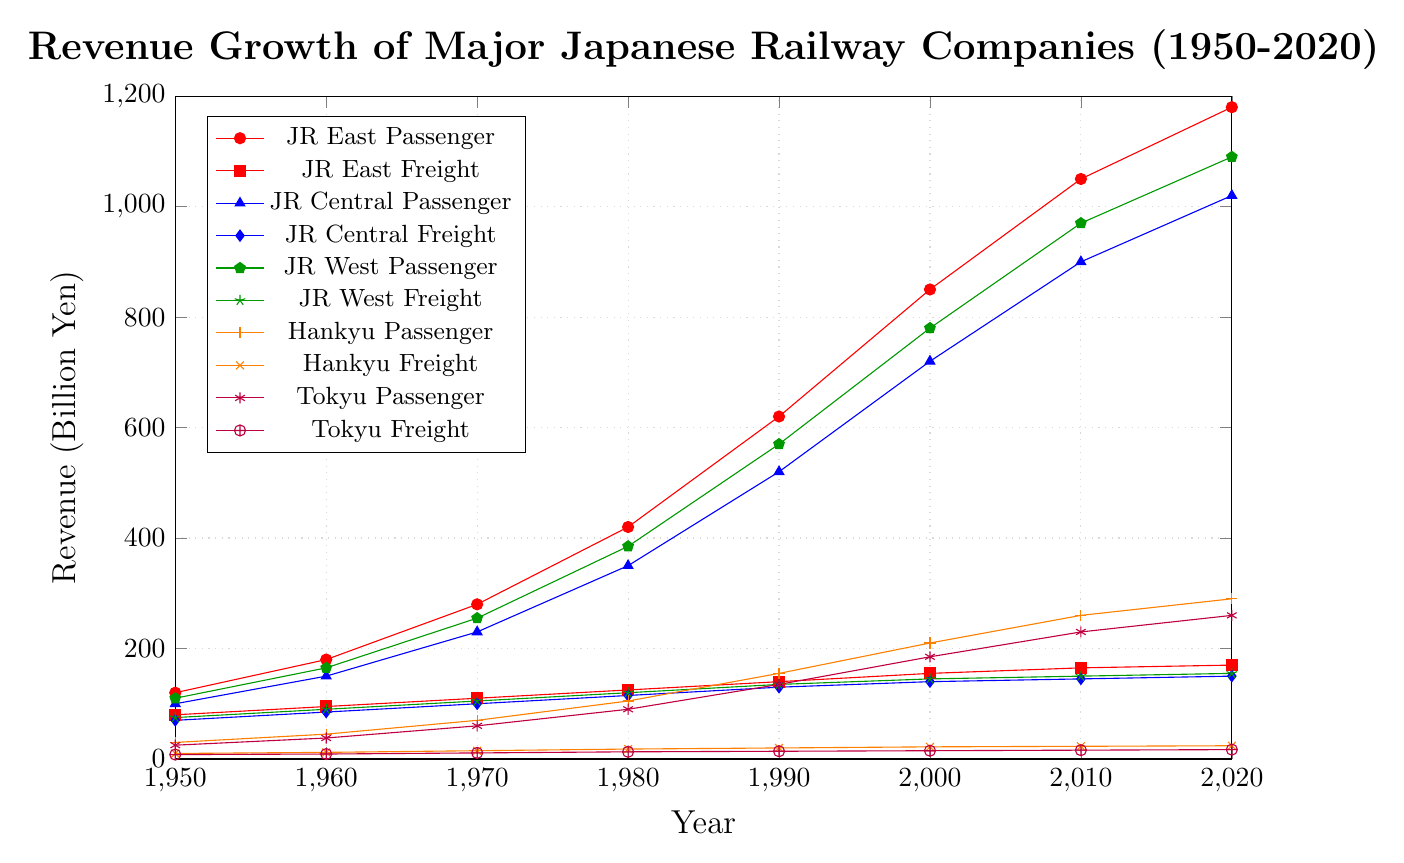Which company had the highest revenue from passenger services in 2020? The chart shows revenue from passenger services for JR East, JR Central, JR West, Hankyu, and Tokyu. By identifying the highest point among these for 2020, we find that JR East had the highest revenue from passenger services.
Answer: JR East How did the revenue from freight services for JR East change from 1950 to 2020? Observing the line representing JR East Freight from 1950 to 2020, it shows an increase from 80 billion yen to 170 billion yen. The detailed changes are minor but consistently upward.
Answer: Increased What was the difference in revenue from passenger services between JR Central and Hankyu in 2000? The revenue for JR Central Passenger in 2000 was 720 billion yen, while for Hankyu Passenger it was 210 billion yen. Subtracting these values gives the difference (720 - 210 = 510).
Answer: 510 billion yen Which had more revenue from freight services in 1990, JR West or JR Central? Comparing the 1990 values for JR West Freight (135 billion yen) and JR Central Freight (130 billion yen), JR West had higher revenue.
Answer: JR West How did Tokyu Passenger revenue growth compare to JR West Passenger revenue growth from 1980 to 2000? Tokyu Passenger revenue grew from 90 billion yen in 1980 to 185 billion yen in 2000, an increase of 95 billion yen. JR West Passenger grew from 385 billion yen to 780 billion yen, an increase of 395 billion yen. JR West Passenger had a significantly higher growth.
Answer: JR West Passenger had higher growth What is the sum of freight revenues for JR East and JR Central in 2010? In 2010, JR East Freight revenue was 165 billion yen, and JR Central Freight revenue was 145 billion yen. Adding these gives (165 + 145) = 310 billion yen.
Answer: 310 billion yen Which company experienced the highest increase in passenger service revenue between 1970 and 2020? Calculating the difference for each company over these years: JR East (1180 - 280 = 900), JR Central (1020 - 230 = 790), JR West (1090 - 255 = 835), Hankyu (290 - 70 = 220), Tokyu (260 - 60 = 200). JR East experienced the highest increase.
Answer: JR East What's the average revenue from freight services for Tokyu from 1950 to 2020? The revenues are 8, 9, 11, 13, 14, 15, 16, 17. Summing these gives 103; the number of data points is 8, so the average is (103 / 8) = 12.875 billion yen.
Answer: 12.875 billion yen 